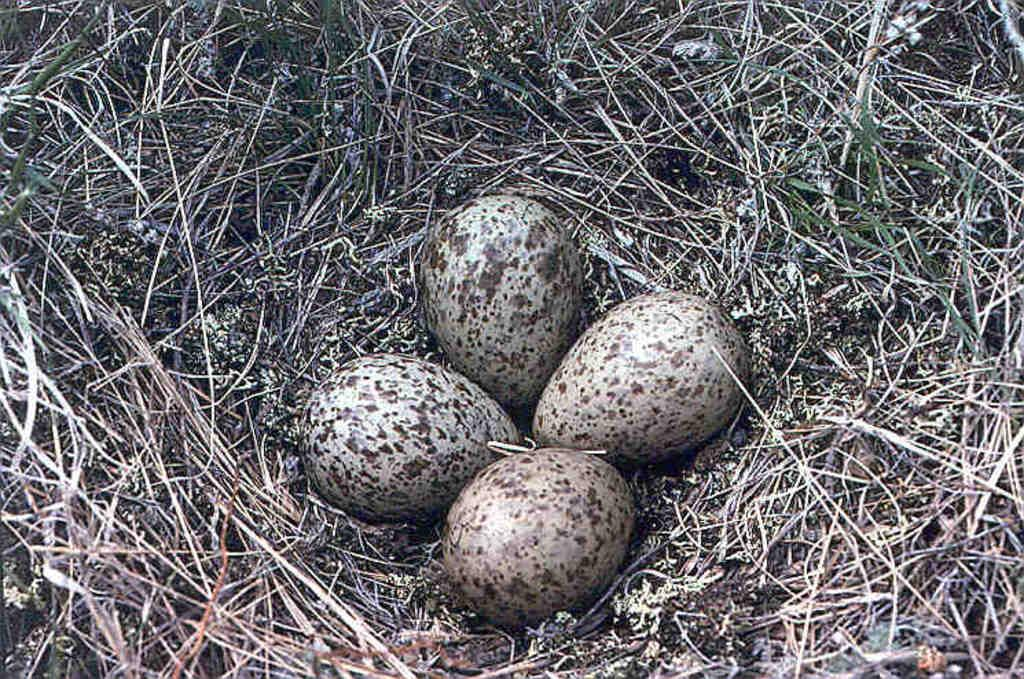How many eggs are visible in the image? There are four eggs in the image. What type of vegetation can be seen in the image? There is grass in the image. Can you determine the time of day when the image was taken? Yes, the image was taken during the day. What type of lizards can be seen crawling on the eggs in the image? There are no lizards present in the image; it only shows four eggs and grass. What type of trade is being conducted in the image? There is no trade being conducted in the image; it only shows four eggs and grass. 